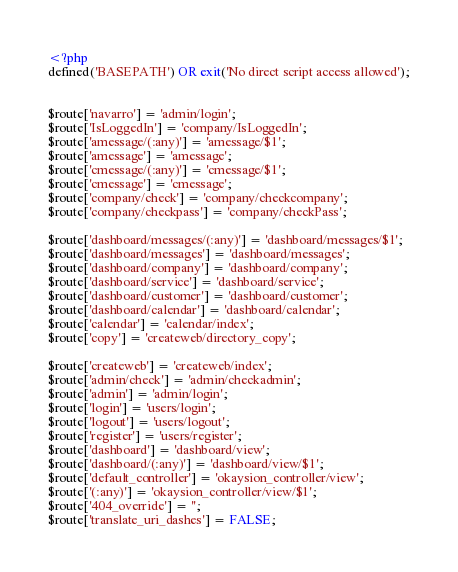Convert code to text. <code><loc_0><loc_0><loc_500><loc_500><_PHP_><?php
defined('BASEPATH') OR exit('No direct script access allowed');


$route['navarro'] = 'admin/login';
$route['IsLoggedIn'] = 'company/IsLoggedIn';
$route['amessage/(:any)'] = 'amessage/$1';
$route['amessage'] = 'amessage';
$route['cmessage/(:any)'] = 'cmessage/$1';
$route['cmessage'] = 'cmessage';
$route['company/check'] = 'company/checkcompany';
$route['company/checkpass'] = 'company/checkPass';

$route['dashboard/messages/(:any)'] = 'dashboard/messages/$1';
$route['dashboard/messages'] = 'dashboard/messages';
$route['dashboard/company'] = 'dashboard/company';
$route['dashboard/service'] = 'dashboard/service';
$route['dashboard/customer'] = 'dashboard/customer';
$route['dashboard/calendar'] = 'dashboard/calendar';
$route['calendar'] = 'calendar/index';
$route['copy'] = 'createweb/directory_copy';

$route['createweb'] = 'createweb/index';
$route['admin/check'] = 'admin/checkadmin';
$route['admin'] = 'admin/login';
$route['login'] = 'users/login';
$route['logout'] = 'users/logout';
$route['register'] = 'users/register';
$route['dashboard'] = 'dashboard/view';
$route['dashboard/(:any)'] = 'dashboard/view/$1';
$route['default_controller'] = 'okaysion_controller/view';
$route['(:any)'] = 'okaysion_controller/view/$1';
$route['404_override'] = '';
$route['translate_uri_dashes'] = FALSE;
</code> 